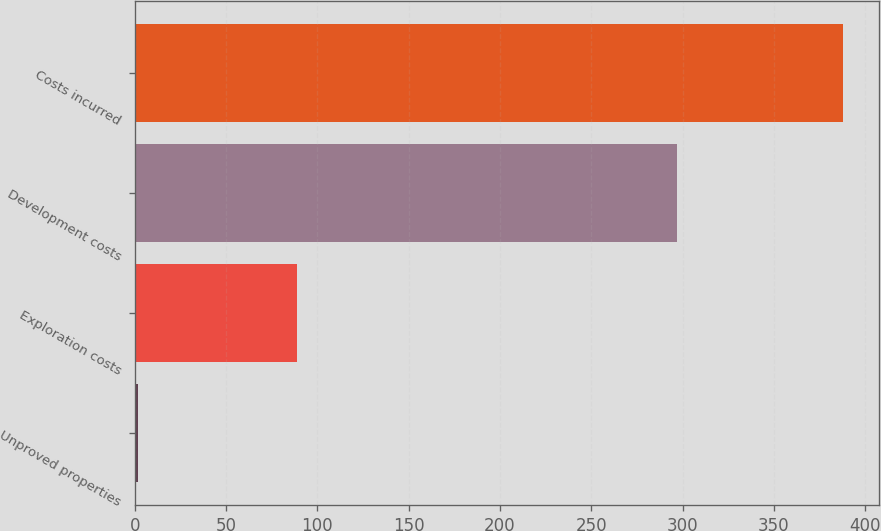Convert chart. <chart><loc_0><loc_0><loc_500><loc_500><bar_chart><fcel>Unproved properties<fcel>Exploration costs<fcel>Development costs<fcel>Costs incurred<nl><fcel>2<fcel>89<fcel>297<fcel>388<nl></chart> 